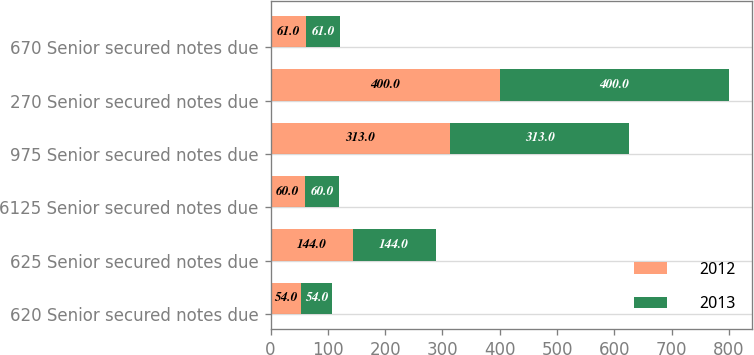Convert chart. <chart><loc_0><loc_0><loc_500><loc_500><stacked_bar_chart><ecel><fcel>620 Senior secured notes due<fcel>625 Senior secured notes due<fcel>6125 Senior secured notes due<fcel>975 Senior secured notes due<fcel>270 Senior secured notes due<fcel>670 Senior secured notes due<nl><fcel>2012<fcel>54<fcel>144<fcel>60<fcel>313<fcel>400<fcel>61<nl><fcel>2013<fcel>54<fcel>144<fcel>60<fcel>313<fcel>400<fcel>61<nl></chart> 